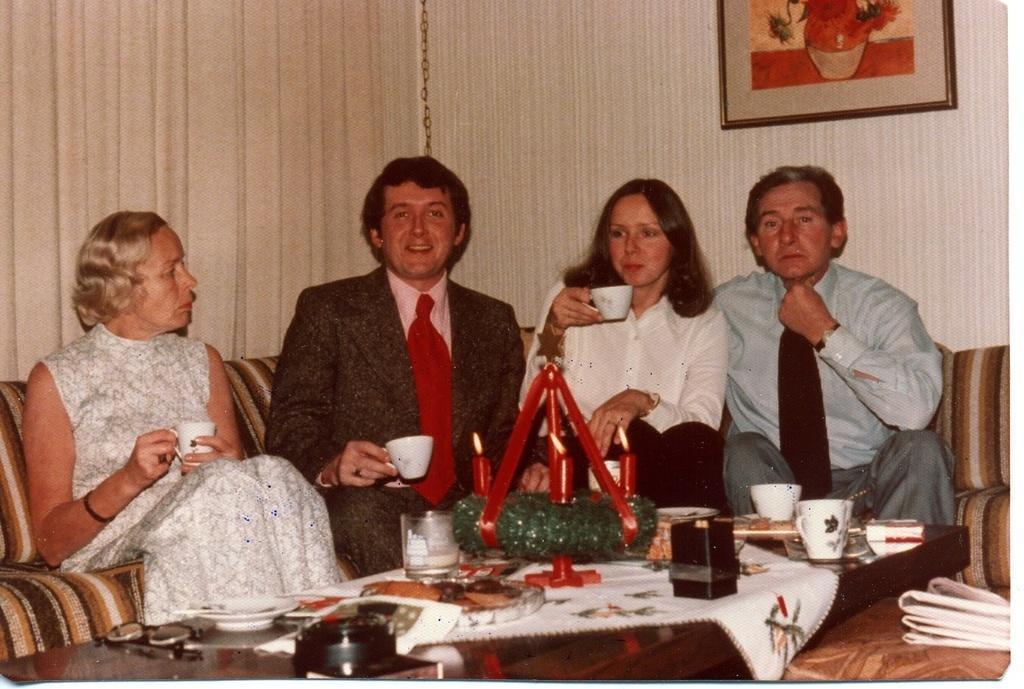Can you describe this image briefly? Four people are sitting in sofa. Of them three are holding a cup in their hand. 